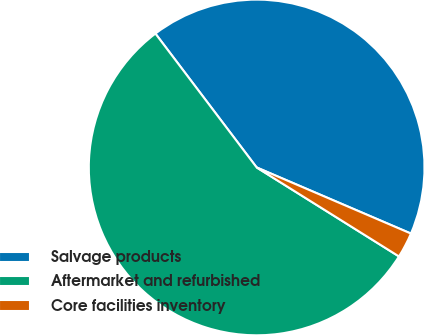Convert chart to OTSL. <chart><loc_0><loc_0><loc_500><loc_500><pie_chart><fcel>Salvage products<fcel>Aftermarket and refurbished<fcel>Core facilities inventory<nl><fcel>41.75%<fcel>55.8%<fcel>2.45%<nl></chart> 